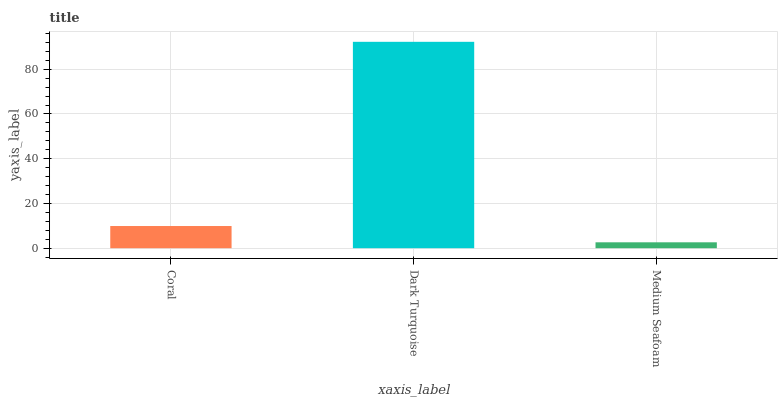Is Medium Seafoam the minimum?
Answer yes or no. Yes. Is Dark Turquoise the maximum?
Answer yes or no. Yes. Is Dark Turquoise the minimum?
Answer yes or no. No. Is Medium Seafoam the maximum?
Answer yes or no. No. Is Dark Turquoise greater than Medium Seafoam?
Answer yes or no. Yes. Is Medium Seafoam less than Dark Turquoise?
Answer yes or no. Yes. Is Medium Seafoam greater than Dark Turquoise?
Answer yes or no. No. Is Dark Turquoise less than Medium Seafoam?
Answer yes or no. No. Is Coral the high median?
Answer yes or no. Yes. Is Coral the low median?
Answer yes or no. Yes. Is Dark Turquoise the high median?
Answer yes or no. No. Is Medium Seafoam the low median?
Answer yes or no. No. 